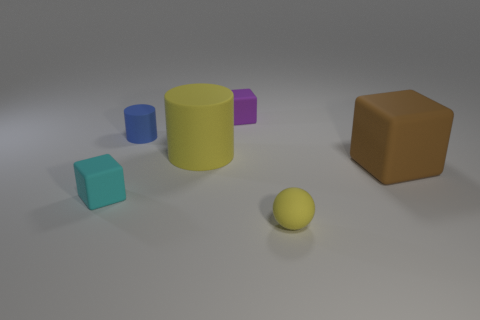Subtract all brown matte blocks. How many blocks are left? 2 Add 2 small brown shiny things. How many objects exist? 8 Subtract all brown cubes. How many cubes are left? 2 Subtract all brown cubes. How many purple spheres are left? 0 Subtract all yellow matte balls. Subtract all large blocks. How many objects are left? 4 Add 4 brown matte cubes. How many brown matte cubes are left? 5 Add 1 cyan rubber things. How many cyan rubber things exist? 2 Subtract 1 brown blocks. How many objects are left? 5 Subtract all cylinders. How many objects are left? 4 Subtract 1 cylinders. How many cylinders are left? 1 